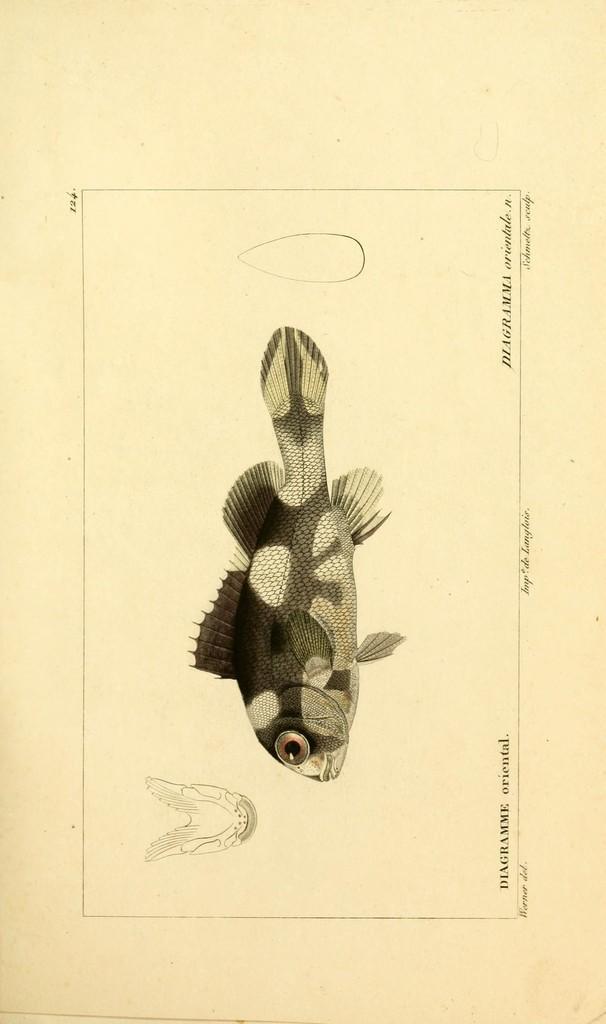Can you describe this image briefly? In this image we can see drawings and something written on this picture. 